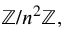Convert formula to latex. <formula><loc_0><loc_0><loc_500><loc_500>\mathbb { Z } / n ^ { 2 } \mathbb { Z } ,</formula> 